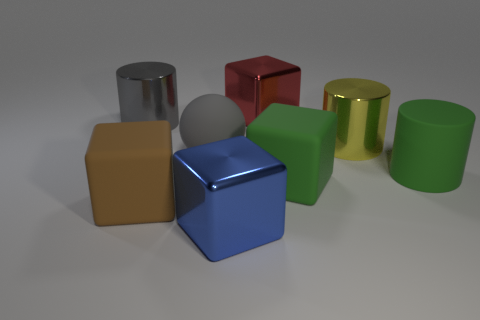Subtract all big brown matte blocks. How many blocks are left? 3 Add 2 red things. How many objects exist? 10 Subtract 2 cubes. How many cubes are left? 2 Subtract all red cubes. How many cubes are left? 3 Subtract all spheres. How many objects are left? 7 Add 8 big brown rubber objects. How many big brown rubber objects are left? 9 Add 1 small matte balls. How many small matte balls exist? 1 Subtract 0 brown balls. How many objects are left? 8 Subtract all green cubes. Subtract all cyan cylinders. How many cubes are left? 3 Subtract all big red metallic objects. Subtract all big green matte things. How many objects are left? 5 